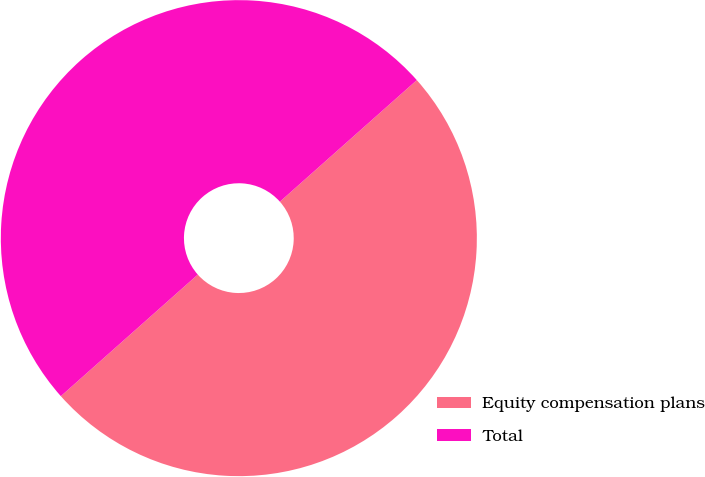Convert chart to OTSL. <chart><loc_0><loc_0><loc_500><loc_500><pie_chart><fcel>Equity compensation plans<fcel>Total<nl><fcel>50.0%<fcel>50.0%<nl></chart> 